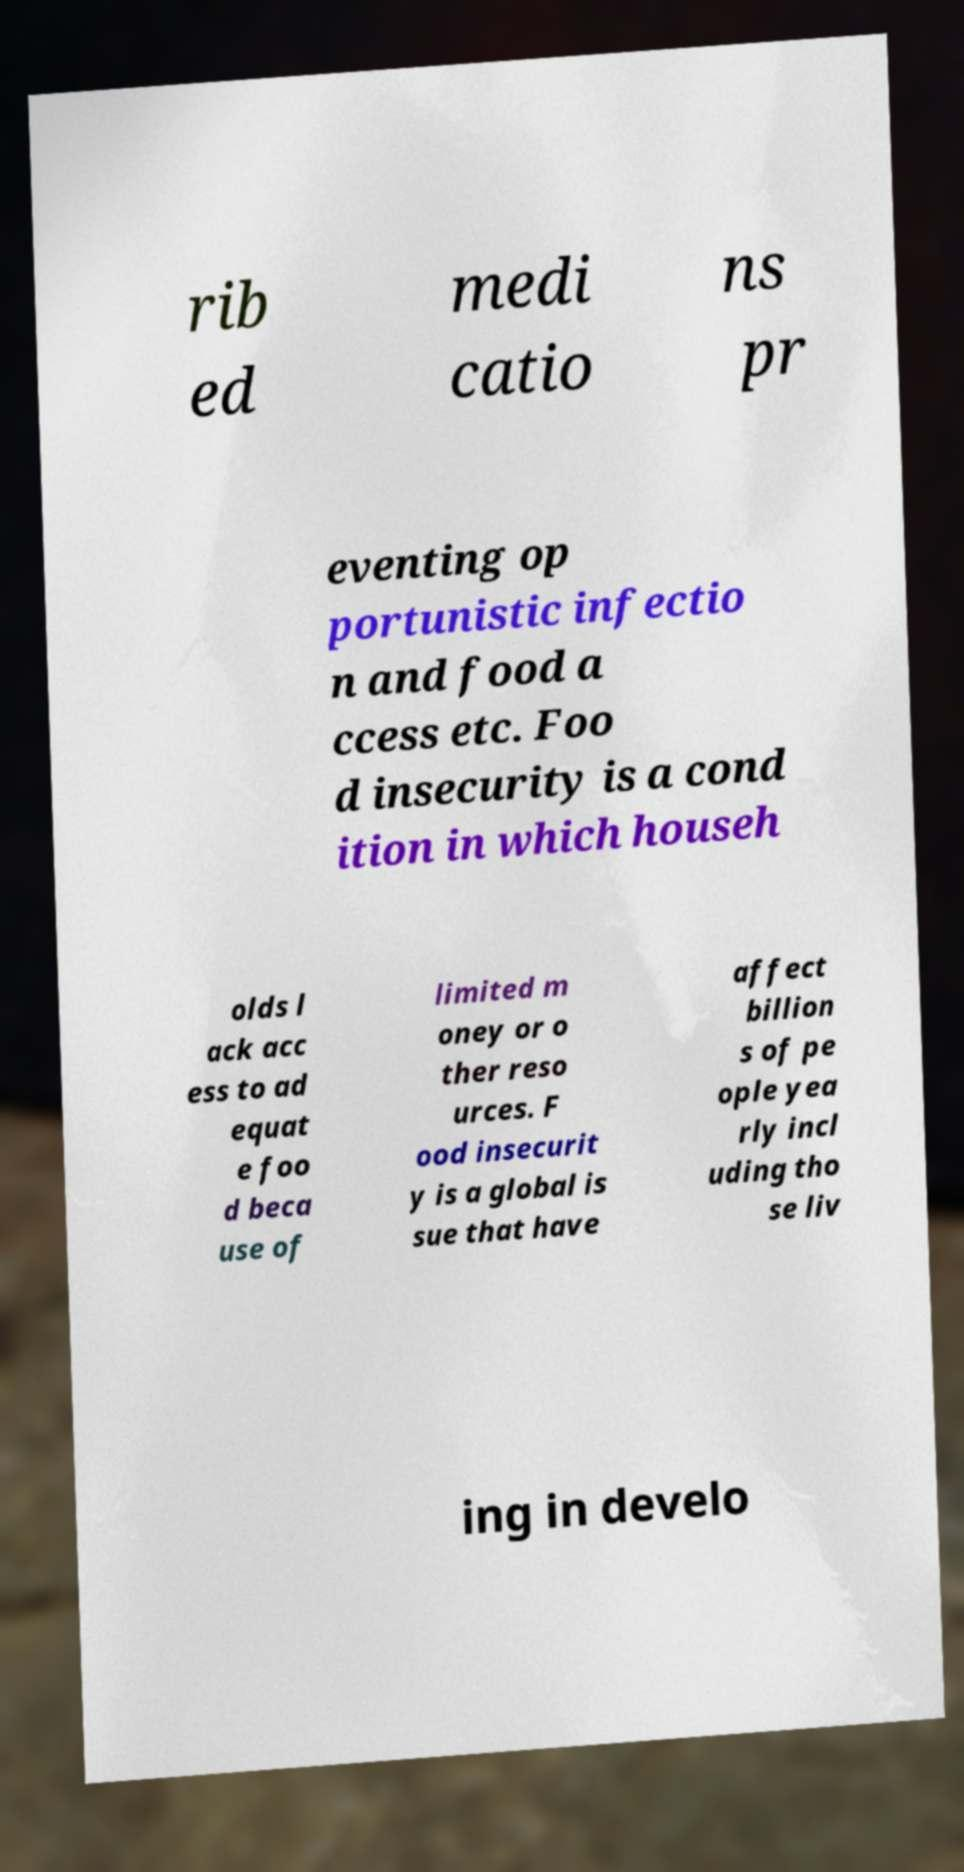For documentation purposes, I need the text within this image transcribed. Could you provide that? rib ed medi catio ns pr eventing op portunistic infectio n and food a ccess etc. Foo d insecurity is a cond ition in which househ olds l ack acc ess to ad equat e foo d beca use of limited m oney or o ther reso urces. F ood insecurit y is a global is sue that have affect billion s of pe ople yea rly incl uding tho se liv ing in develo 